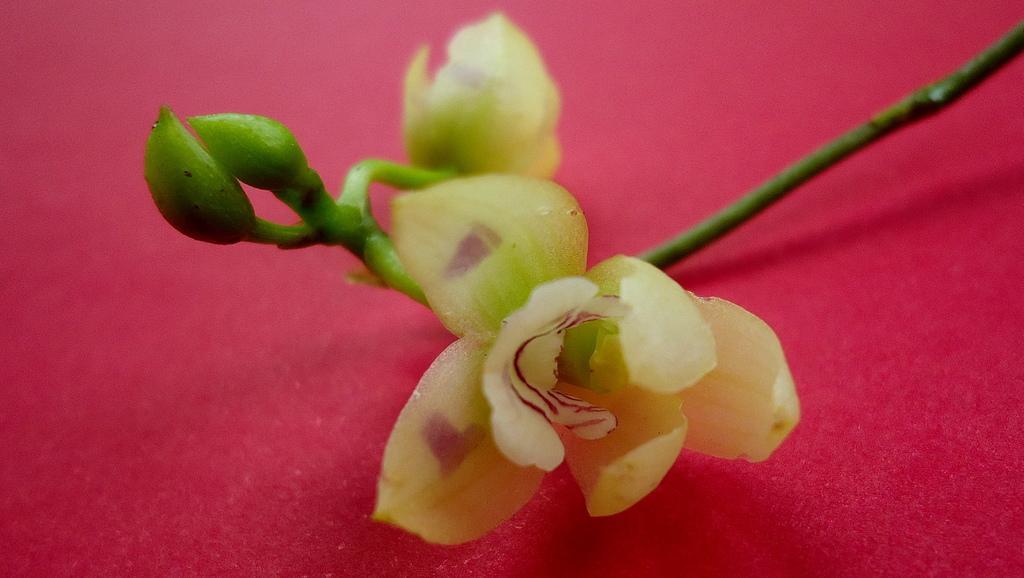Please provide a concise description of this image. In this image we can see flowers and buds on a red surface. 